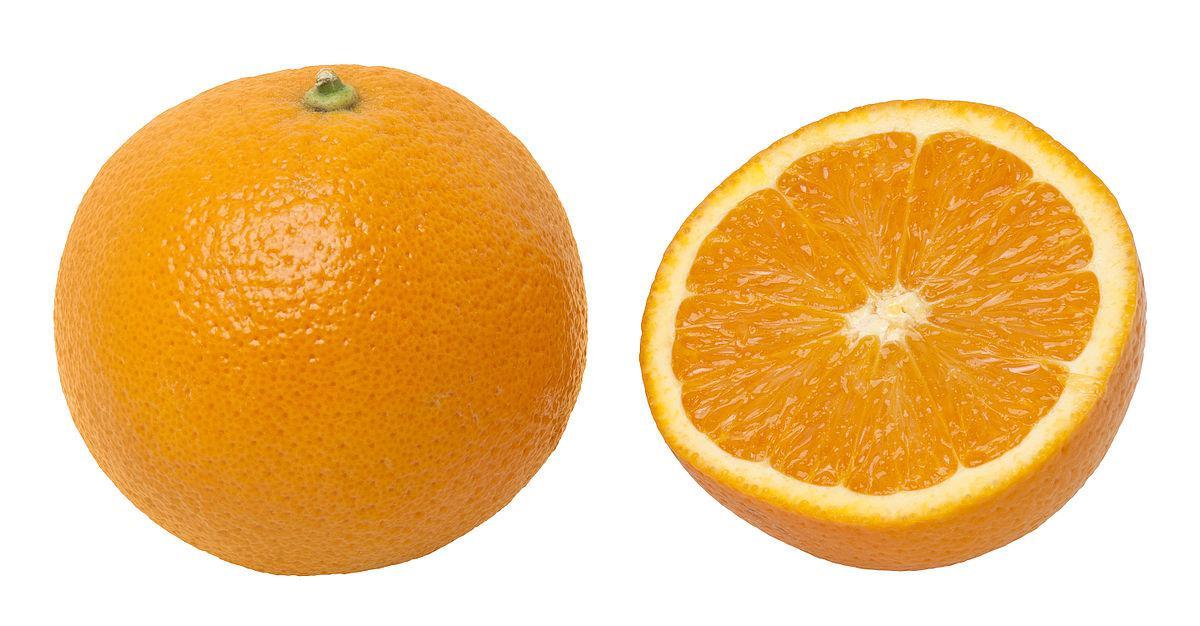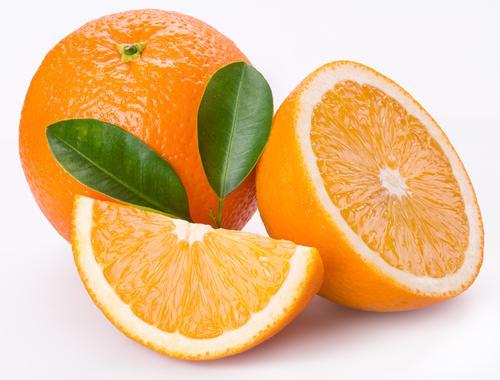The first image is the image on the left, the second image is the image on the right. Given the left and right images, does the statement "The left image contains only a half orange next to a whole orange, and the right image includes a half orange, orange wedge, whole orange, and green leaves." hold true? Answer yes or no. Yes. The first image is the image on the left, the second image is the image on the right. For the images displayed, is the sentence "In at least one image there are three parallel orange leaves next to no more then three full oranges." factually correct? Answer yes or no. No. 